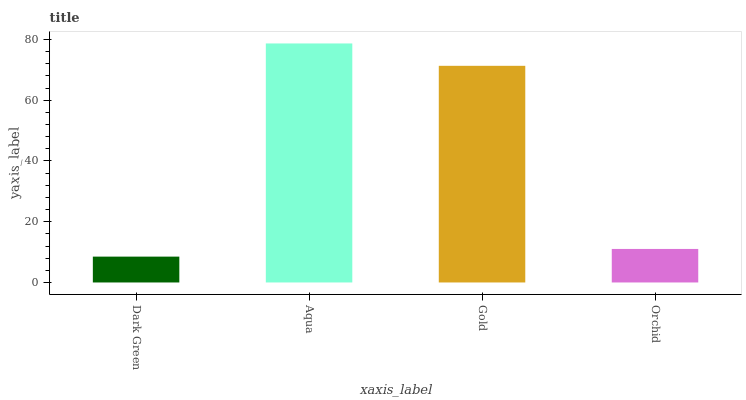Is Dark Green the minimum?
Answer yes or no. Yes. Is Aqua the maximum?
Answer yes or no. Yes. Is Gold the minimum?
Answer yes or no. No. Is Gold the maximum?
Answer yes or no. No. Is Aqua greater than Gold?
Answer yes or no. Yes. Is Gold less than Aqua?
Answer yes or no. Yes. Is Gold greater than Aqua?
Answer yes or no. No. Is Aqua less than Gold?
Answer yes or no. No. Is Gold the high median?
Answer yes or no. Yes. Is Orchid the low median?
Answer yes or no. Yes. Is Orchid the high median?
Answer yes or no. No. Is Aqua the low median?
Answer yes or no. No. 